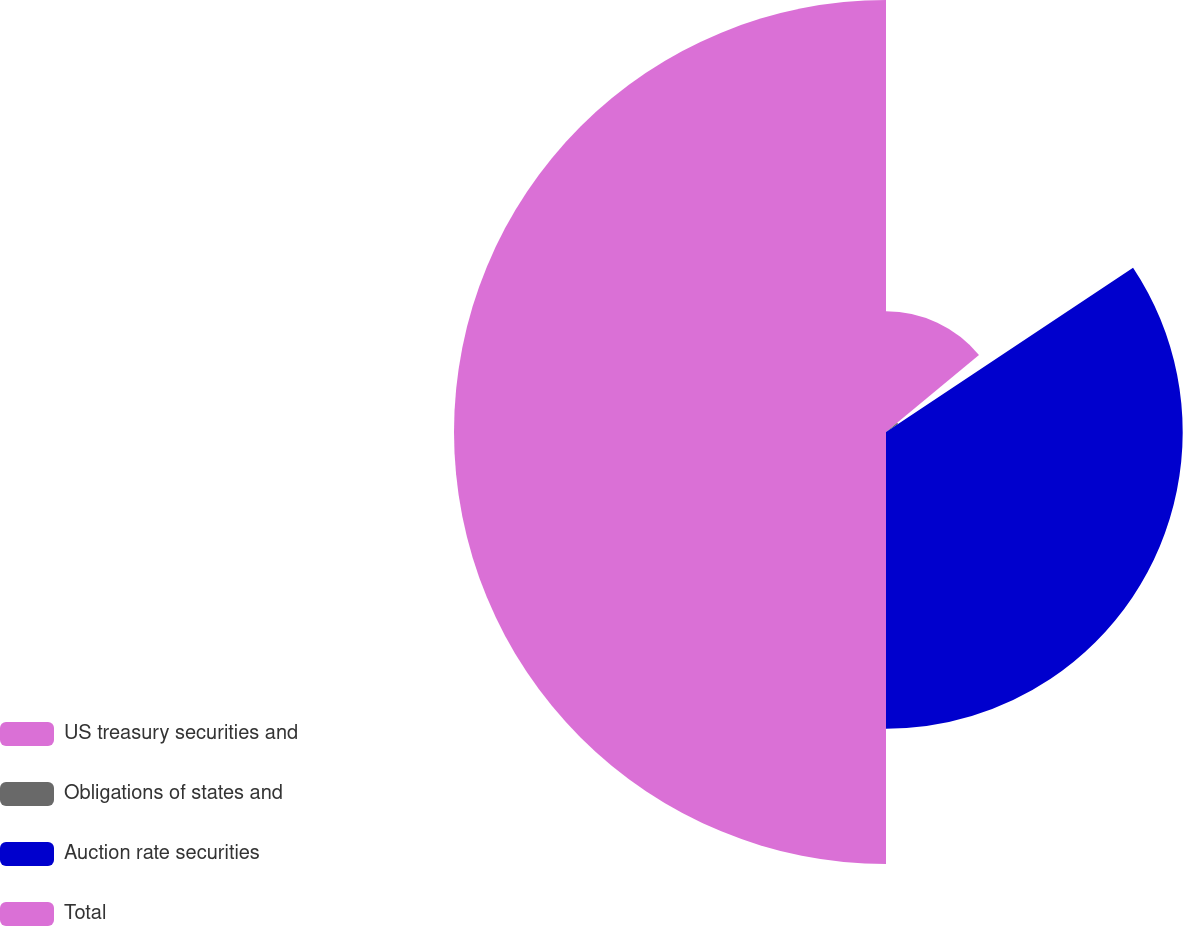<chart> <loc_0><loc_0><loc_500><loc_500><pie_chart><fcel>US treasury securities and<fcel>Obligations of states and<fcel>Auction rate securities<fcel>Total<nl><fcel>13.98%<fcel>1.68%<fcel>34.34%<fcel>50.0%<nl></chart> 